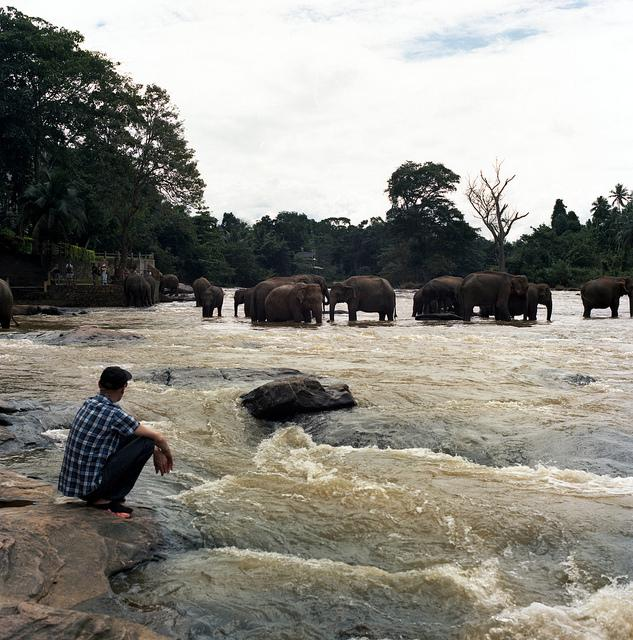What poses the greatest immediate danger to the man?

Choices:
A) rockslide
B) waves
C) tiger
D) spiders waves 